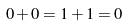<formula> <loc_0><loc_0><loc_500><loc_500>0 + 0 = 1 + 1 = 0</formula> 